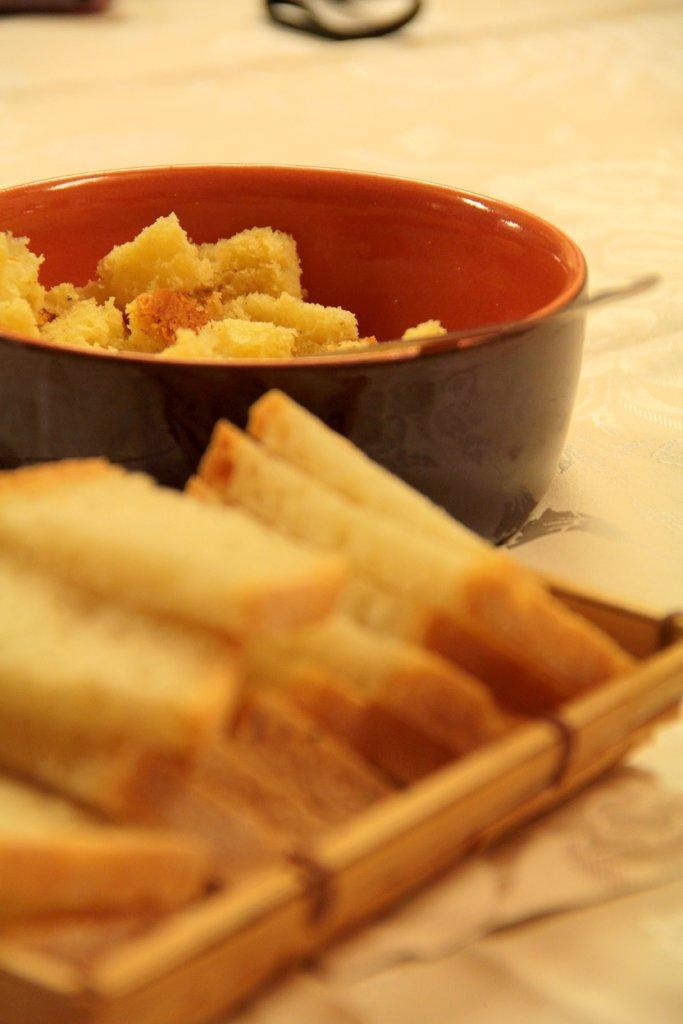What is present in the image that can hold food? There is a bowl in the image that can hold food. What other item is present in the image that can hold multiple food items? There is a tray in the image that can hold multiple food items. Can you describe the food items visible in the image? Unfortunately, the facts provided do not specify the type of food items present in the image. How does the lock keep the food items secure in the image? There is no mention of a lock in the image. --- Facts: 1. There is a person in the image. 2. The person is wearing a hat. 3. The person is holding a book. 4. The background of the image is a library. Absurd Topics: elephant, piano, ocean Conversation: What is present in the image? There is a person in the image. Can you describe the person's attire? The person is wearing a hat. What is the person holding in the image? The person is holding a book. Can you describe the setting of the image? The background of the image is a library. Reasoning: Let's think step by step in order to produce the conversation. We start by identifying the main subject of the image, which is the person. Next, we describe specific features of the person, such as the hat. Then, we observe the actions of the person, noting that they are holding a book. Finally, we describe the setting of the image, which is a library. Absurd Question/Answer: What type of elephant can be seen playing the piano in the image? There is no mention of an elephant or a piano in the image. 